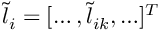Convert formula to latex. <formula><loc_0><loc_0><loc_500><loc_500>\widetilde { l } _ { i } = [ \dots , \widetilde { l } _ { i k } , \dots ] ^ { T }</formula> 